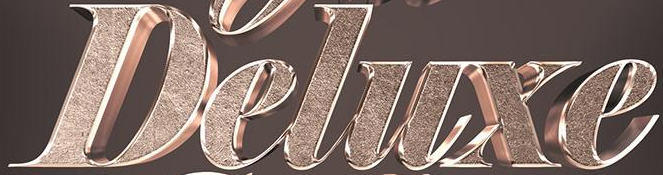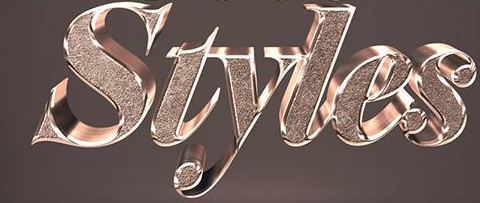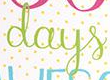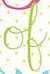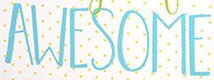What words can you see in these images in sequence, separated by a semicolon? Deluxe; Styles; days; of; AWESOME 